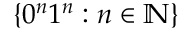<formula> <loc_0><loc_0><loc_500><loc_500>\{ 0 ^ { n } 1 ^ { n } \colon n \in \mathbb { N } \}</formula> 